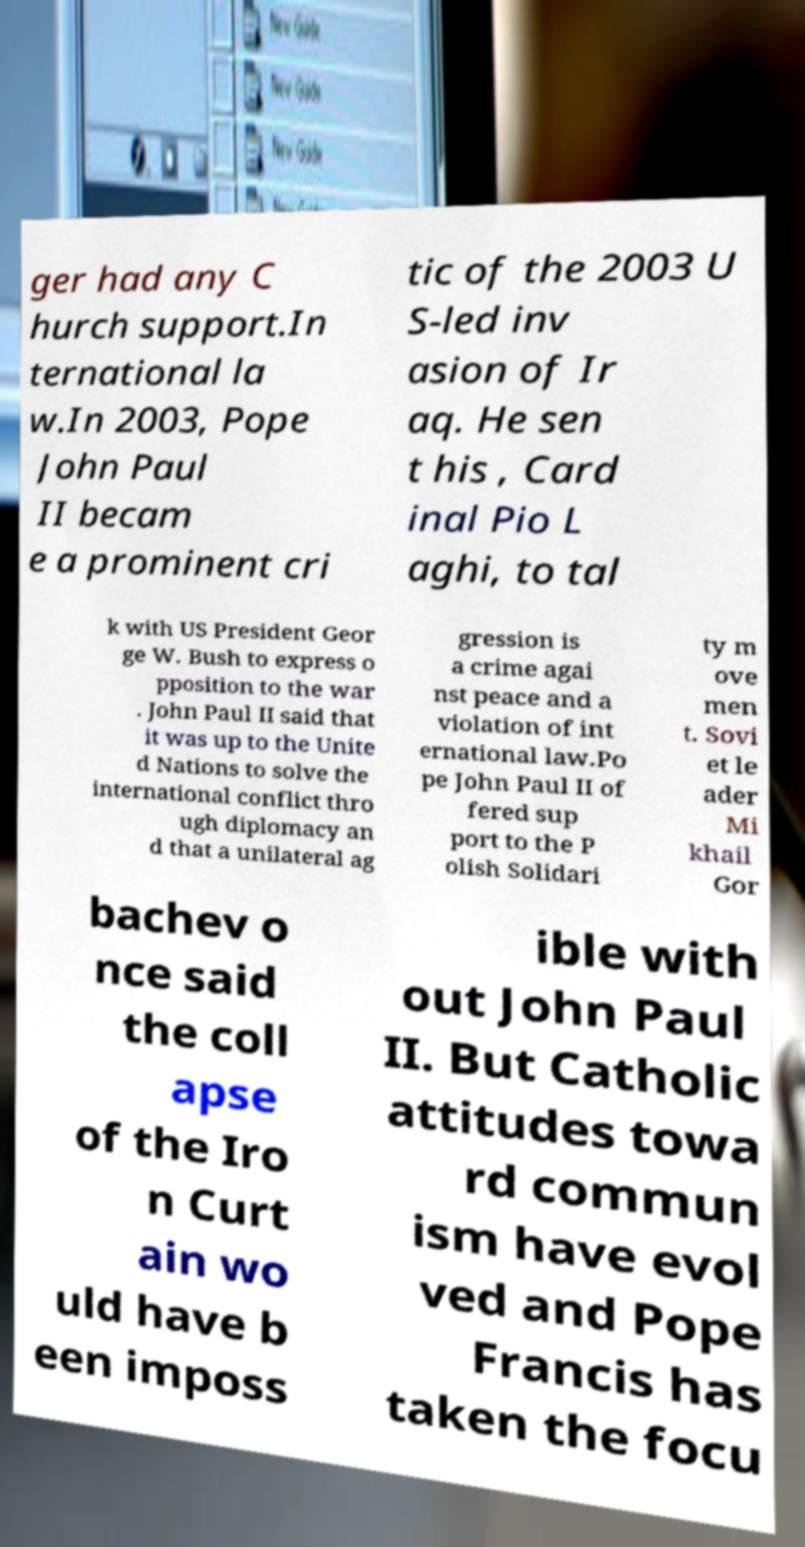Please identify and transcribe the text found in this image. ger had any C hurch support.In ternational la w.In 2003, Pope John Paul II becam e a prominent cri tic of the 2003 U S-led inv asion of Ir aq. He sen t his , Card inal Pio L aghi, to tal k with US President Geor ge W. Bush to express o pposition to the war . John Paul II said that it was up to the Unite d Nations to solve the international conflict thro ugh diplomacy an d that a unilateral ag gression is a crime agai nst peace and a violation of int ernational law.Po pe John Paul II of fered sup port to the P olish Solidari ty m ove men t. Sovi et le ader Mi khail Gor bachev o nce said the coll apse of the Iro n Curt ain wo uld have b een imposs ible with out John Paul II. But Catholic attitudes towa rd commun ism have evol ved and Pope Francis has taken the focu 